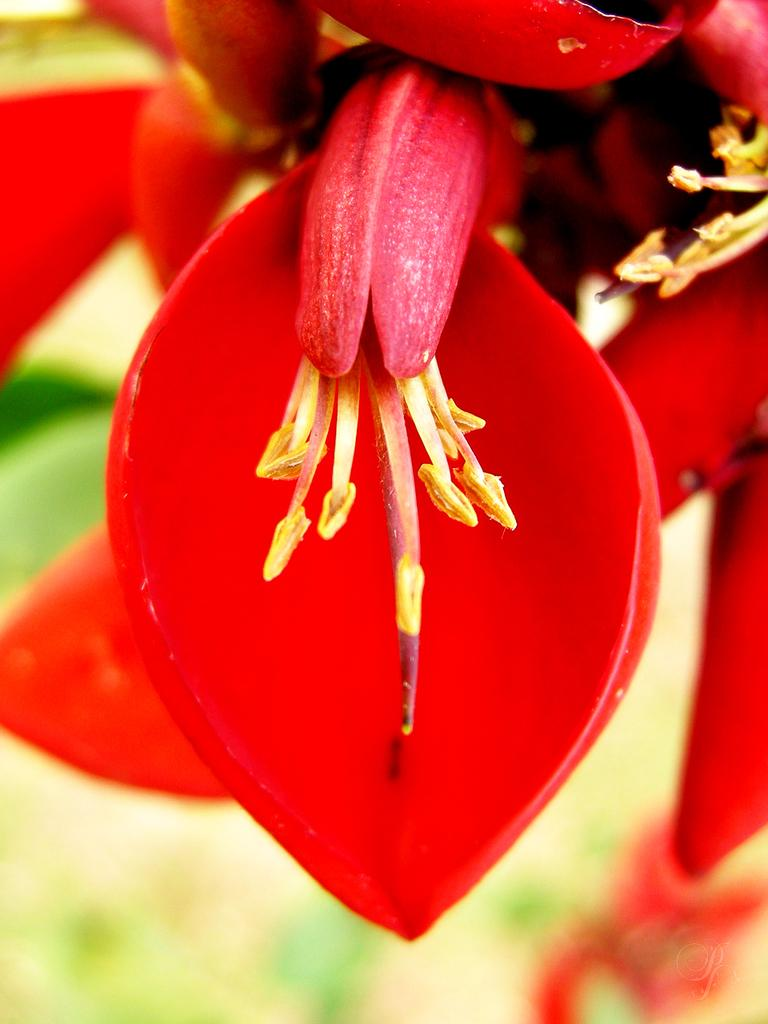What color are the petals of the flower in the image? The petals of the flower in the image are red. How does the flower contribute to pollution in the image? The image does not provide any information about pollution, and the flower itself does not contribute to pollution. 